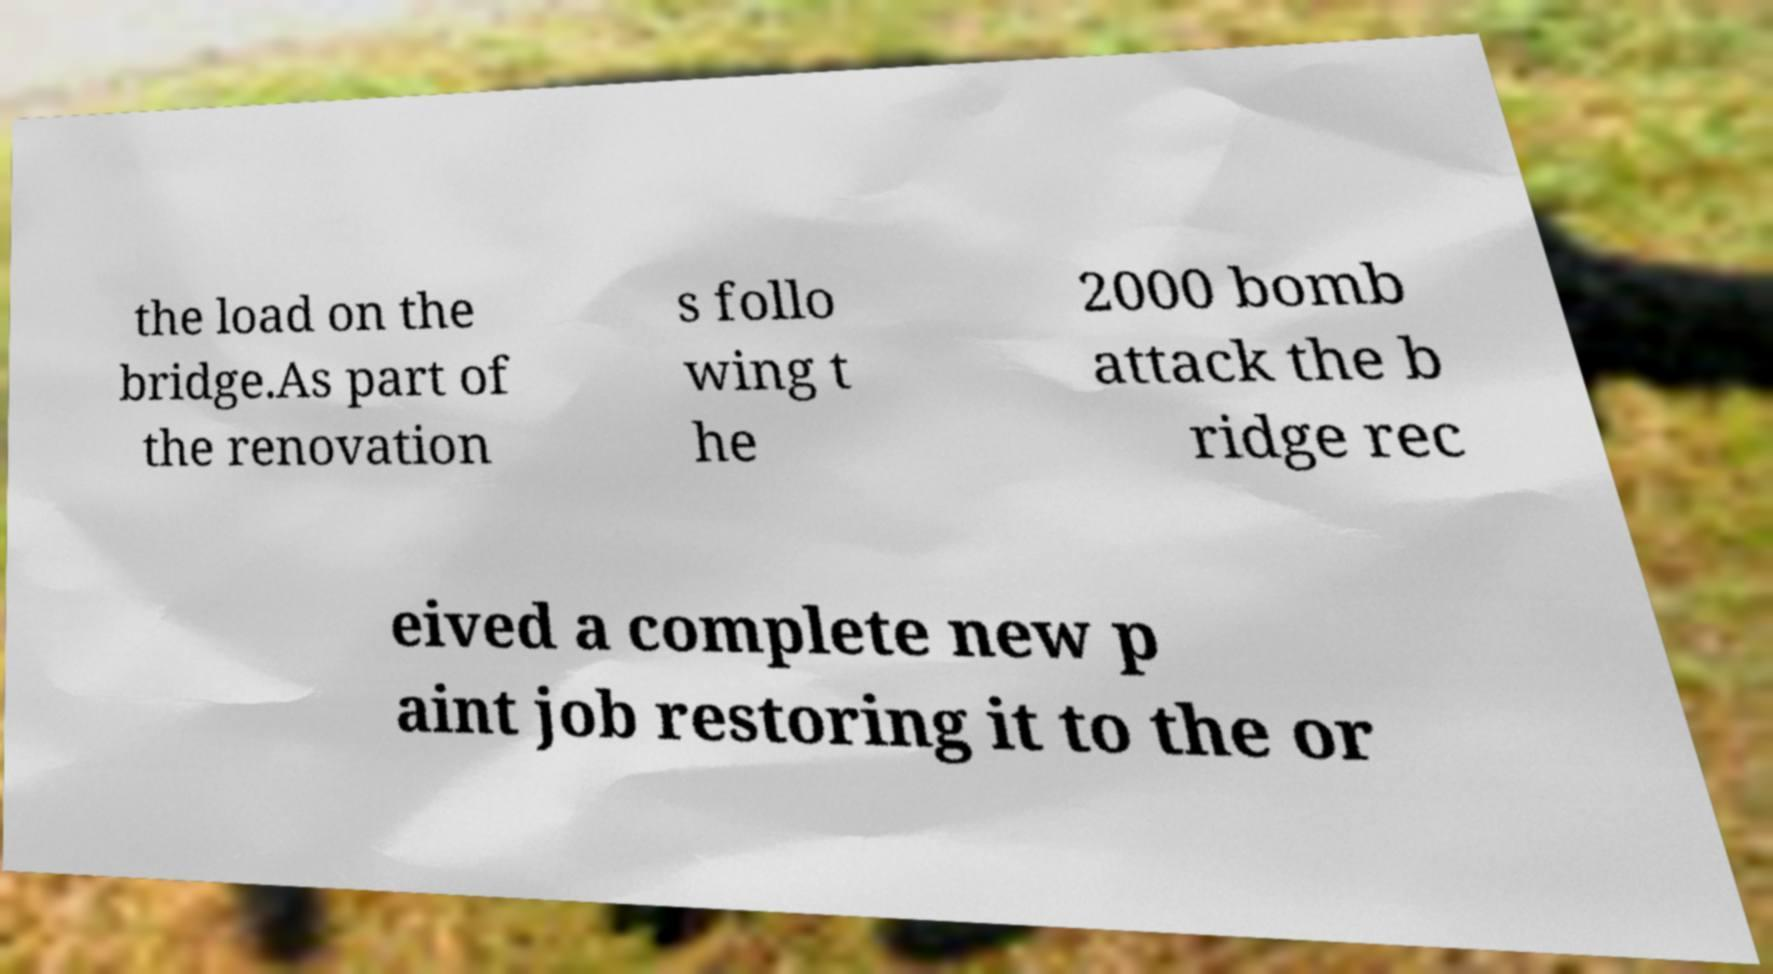Please read and relay the text visible in this image. What does it say? the load on the bridge.As part of the renovation s follo wing t he 2000 bomb attack the b ridge rec eived a complete new p aint job restoring it to the or 